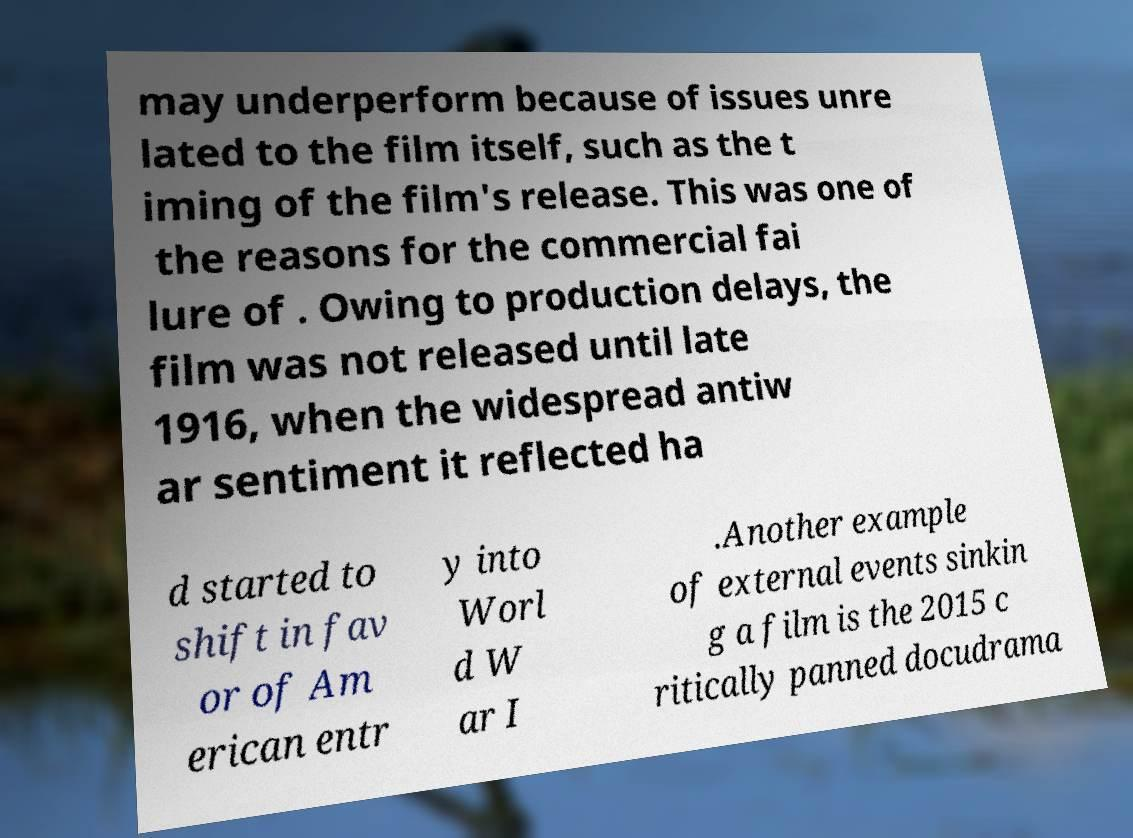I need the written content from this picture converted into text. Can you do that? may underperform because of issues unre lated to the film itself, such as the t iming of the film's release. This was one of the reasons for the commercial fai lure of . Owing to production delays, the film was not released until late 1916, when the widespread antiw ar sentiment it reflected ha d started to shift in fav or of Am erican entr y into Worl d W ar I .Another example of external events sinkin g a film is the 2015 c ritically panned docudrama 